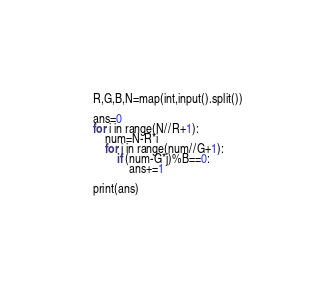Convert code to text. <code><loc_0><loc_0><loc_500><loc_500><_Python_>R,G,B,N=map(int,input().split())

ans=0
for i in range(N//R+1):
    num=N-R*i
    for j in range(num//G+1):
        if (num-G*j)%B==0:
            ans+=1
    
print(ans)</code> 